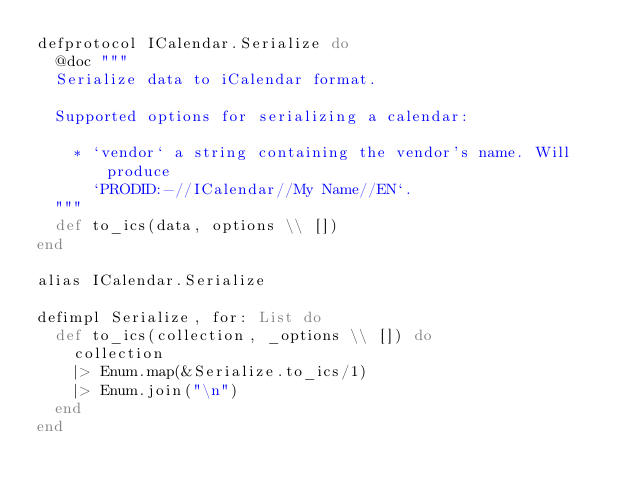Convert code to text. <code><loc_0><loc_0><loc_500><loc_500><_Elixir_>defprotocol ICalendar.Serialize do
  @doc """
  Serialize data to iCalendar format.

  Supported options for serializing a calendar:

    * `vendor` a string containing the vendor's name. Will produce
      `PRODID:-//ICalendar//My Name//EN`.
  """
  def to_ics(data, options \\ [])
end

alias ICalendar.Serialize

defimpl Serialize, for: List do
  def to_ics(collection, _options \\ []) do
    collection
    |> Enum.map(&Serialize.to_ics/1)
    |> Enum.join("\n")
  end
end
</code> 